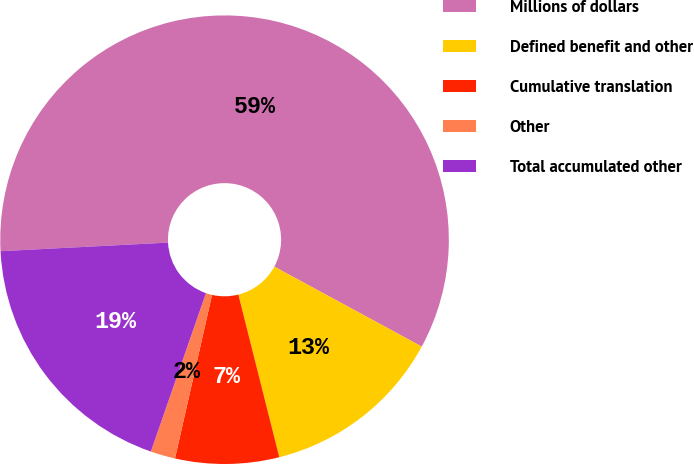Convert chart. <chart><loc_0><loc_0><loc_500><loc_500><pie_chart><fcel>Millions of dollars<fcel>Defined benefit and other<fcel>Cumulative translation<fcel>Other<fcel>Total accumulated other<nl><fcel>58.72%<fcel>13.17%<fcel>7.47%<fcel>1.78%<fcel>18.86%<nl></chart> 